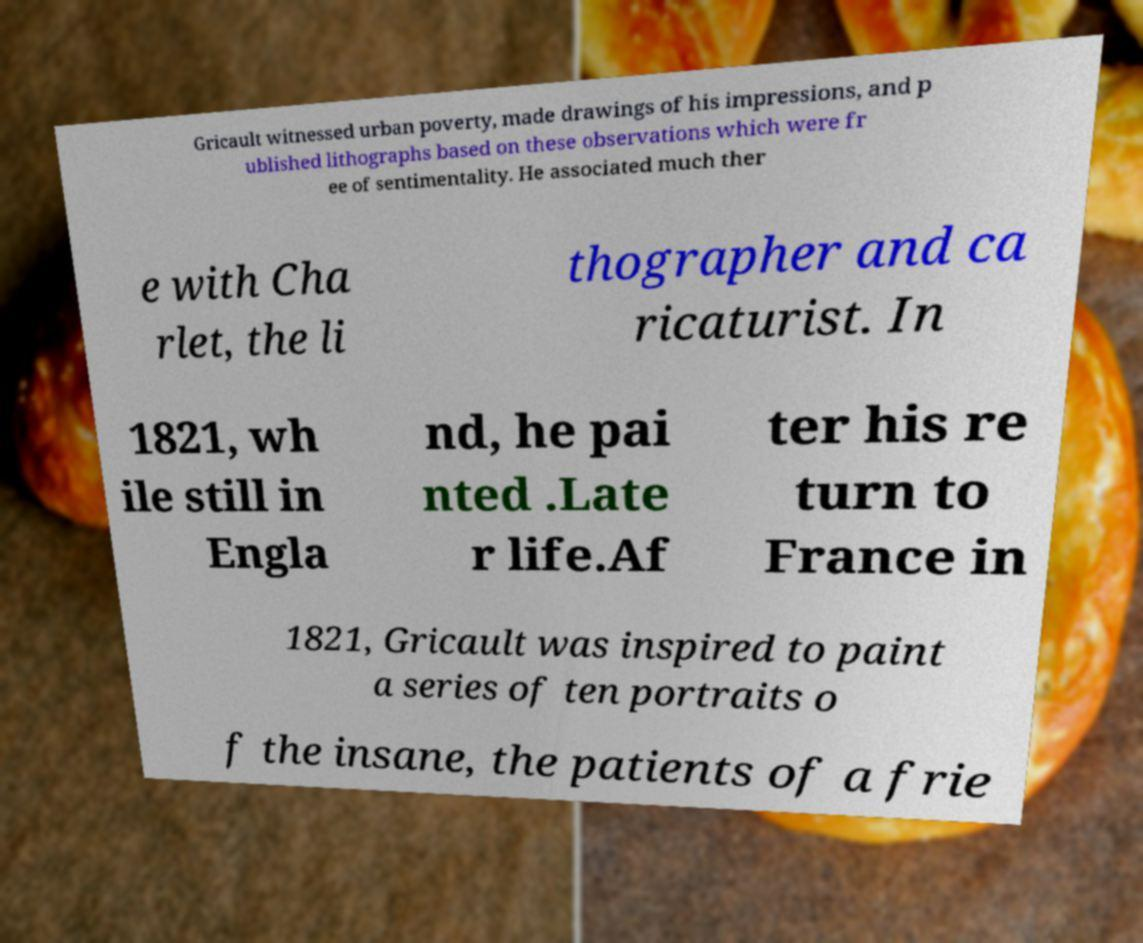Can you read and provide the text displayed in the image?This photo seems to have some interesting text. Can you extract and type it out for me? Gricault witnessed urban poverty, made drawings of his impressions, and p ublished lithographs based on these observations which were fr ee of sentimentality. He associated much ther e with Cha rlet, the li thographer and ca ricaturist. In 1821, wh ile still in Engla nd, he pai nted .Late r life.Af ter his re turn to France in 1821, Gricault was inspired to paint a series of ten portraits o f the insane, the patients of a frie 